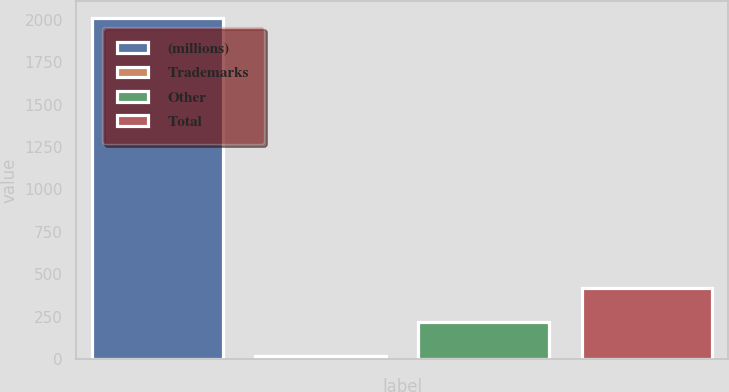Convert chart to OTSL. <chart><loc_0><loc_0><loc_500><loc_500><bar_chart><fcel>(millions)<fcel>Trademarks<fcel>Other<fcel>Total<nl><fcel>2009<fcel>19<fcel>218<fcel>417<nl></chart> 